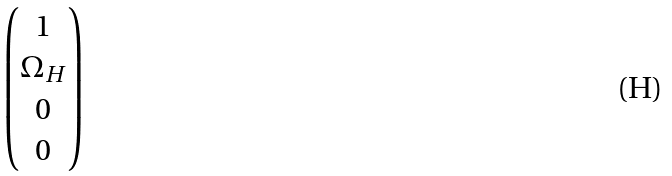Convert formula to latex. <formula><loc_0><loc_0><loc_500><loc_500>\begin{pmatrix} 1 \\ \Omega _ { H } \\ 0 \\ 0 \end{pmatrix}</formula> 